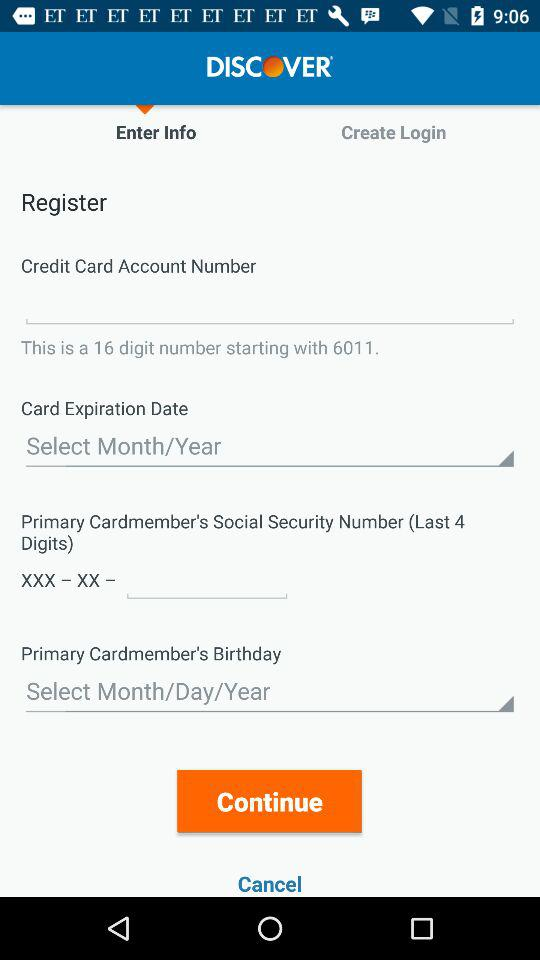How many digits are in the Social Security Number input field?
Answer the question using a single word or phrase. 4 